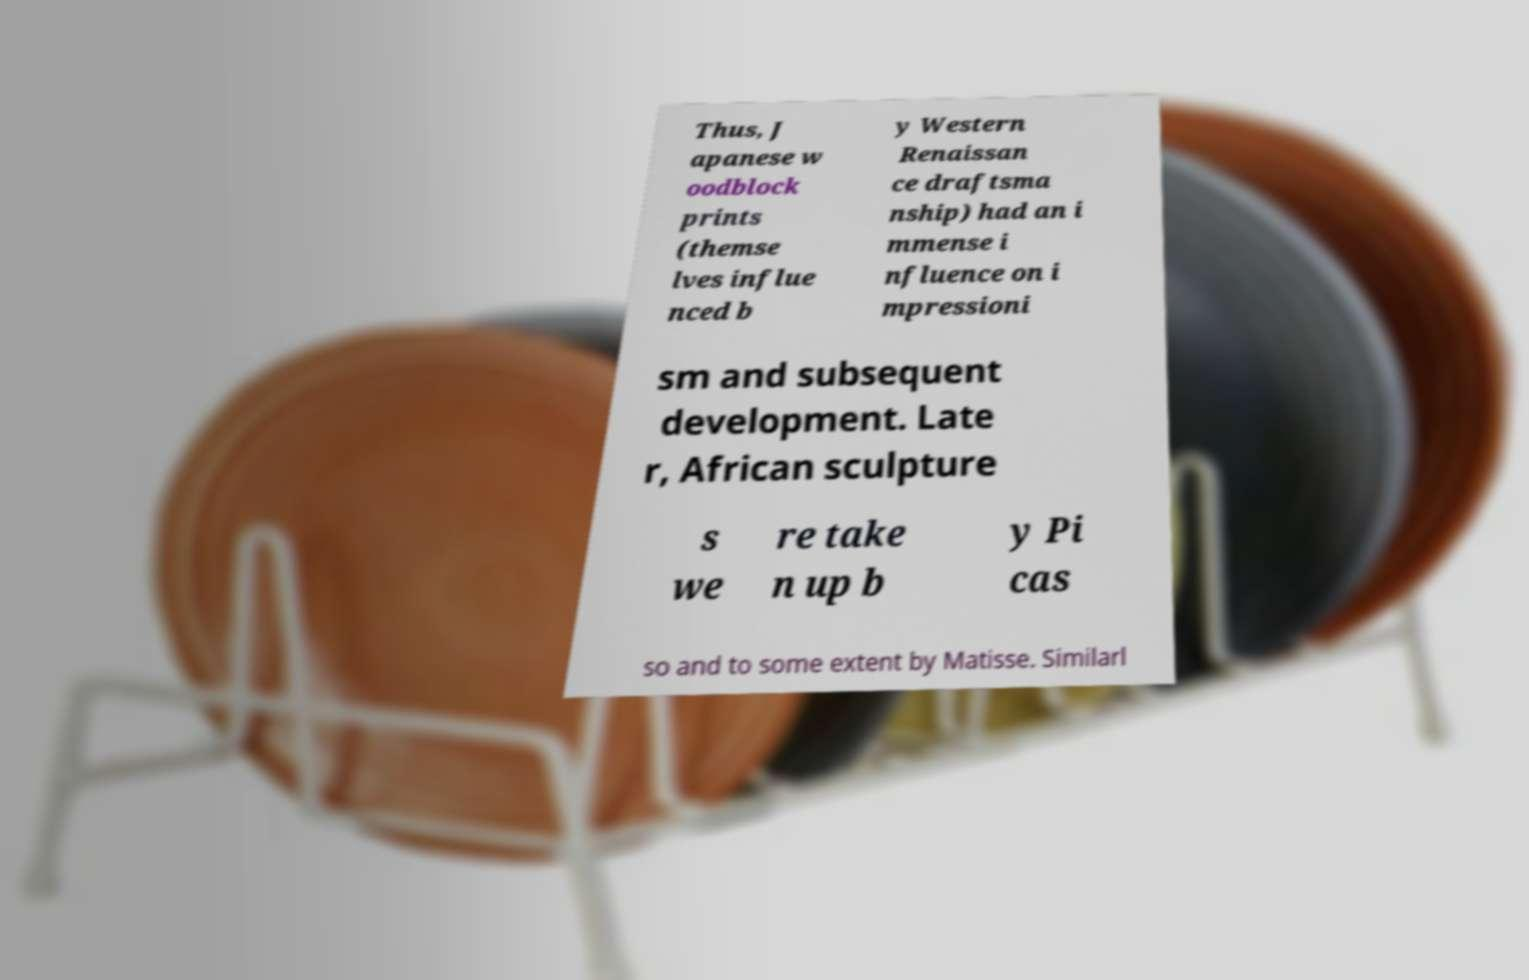I need the written content from this picture converted into text. Can you do that? Thus, J apanese w oodblock prints (themse lves influe nced b y Western Renaissan ce draftsma nship) had an i mmense i nfluence on i mpressioni sm and subsequent development. Late r, African sculpture s we re take n up b y Pi cas so and to some extent by Matisse. Similarl 